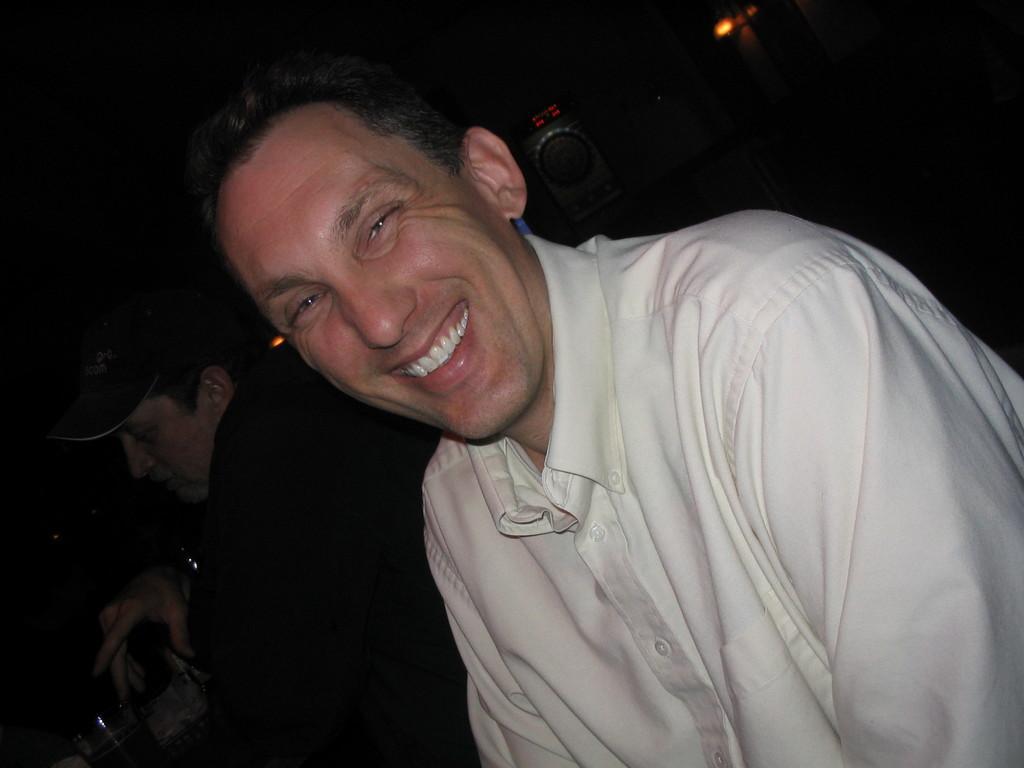How would you summarize this image in a sentence or two? In this image, there are two persons. In the bottom left corner of the image, I can see glasses. Behind the two persons, I can see an object and light. There is a dark background. 